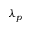Convert formula to latex. <formula><loc_0><loc_0><loc_500><loc_500>\lambda _ { p }</formula> 